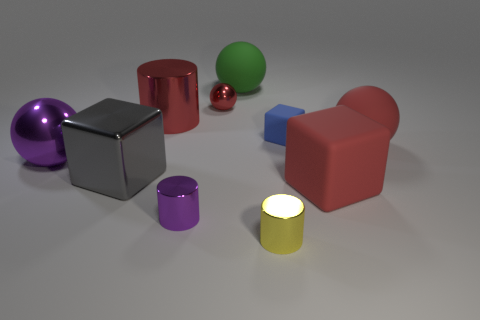There is a small matte object that is the same shape as the gray shiny thing; what color is it?
Your response must be concise. Blue. There is a rubber thing on the left side of the yellow cylinder; is there a metal cylinder that is on the right side of it?
Offer a terse response. Yes. What is the size of the gray object?
Provide a succinct answer. Large. There is a small object that is both behind the small purple metallic thing and left of the green object; what shape is it?
Offer a terse response. Sphere. How many purple objects are small metallic spheres or large shiny balls?
Your answer should be compact. 1. Is the size of the red thing that is in front of the large red ball the same as the red sphere that is to the right of the small red sphere?
Your answer should be very brief. Yes. How many things are either tiny yellow balls or purple spheres?
Provide a short and direct response. 1. Is there a big green matte thing of the same shape as the blue thing?
Ensure brevity in your answer.  No. Are there fewer tiny balls than big matte things?
Your answer should be very brief. Yes. Is the blue object the same shape as the small yellow shiny thing?
Your response must be concise. No. 